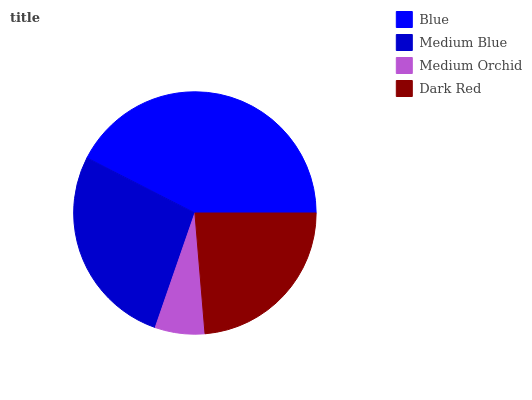Is Medium Orchid the minimum?
Answer yes or no. Yes. Is Blue the maximum?
Answer yes or no. Yes. Is Medium Blue the minimum?
Answer yes or no. No. Is Medium Blue the maximum?
Answer yes or no. No. Is Blue greater than Medium Blue?
Answer yes or no. Yes. Is Medium Blue less than Blue?
Answer yes or no. Yes. Is Medium Blue greater than Blue?
Answer yes or no. No. Is Blue less than Medium Blue?
Answer yes or no. No. Is Medium Blue the high median?
Answer yes or no. Yes. Is Dark Red the low median?
Answer yes or no. Yes. Is Dark Red the high median?
Answer yes or no. No. Is Medium Orchid the low median?
Answer yes or no. No. 